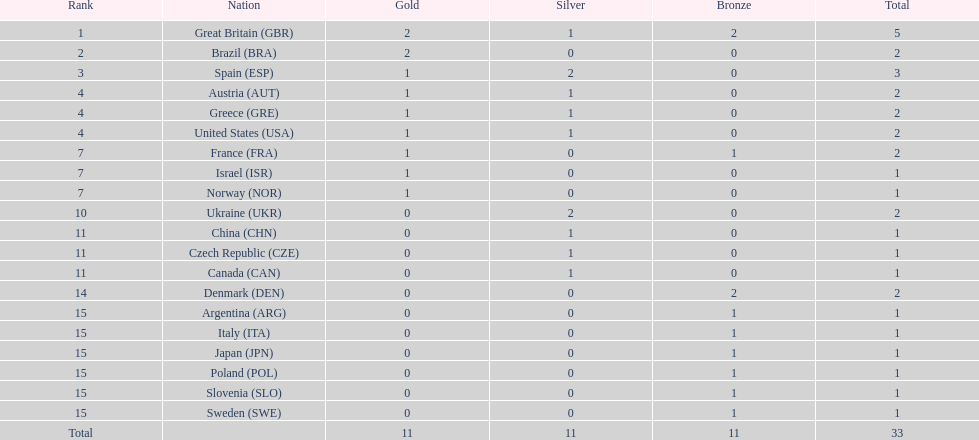How many countries won at least 1 gold and 1 silver medal? 5. 